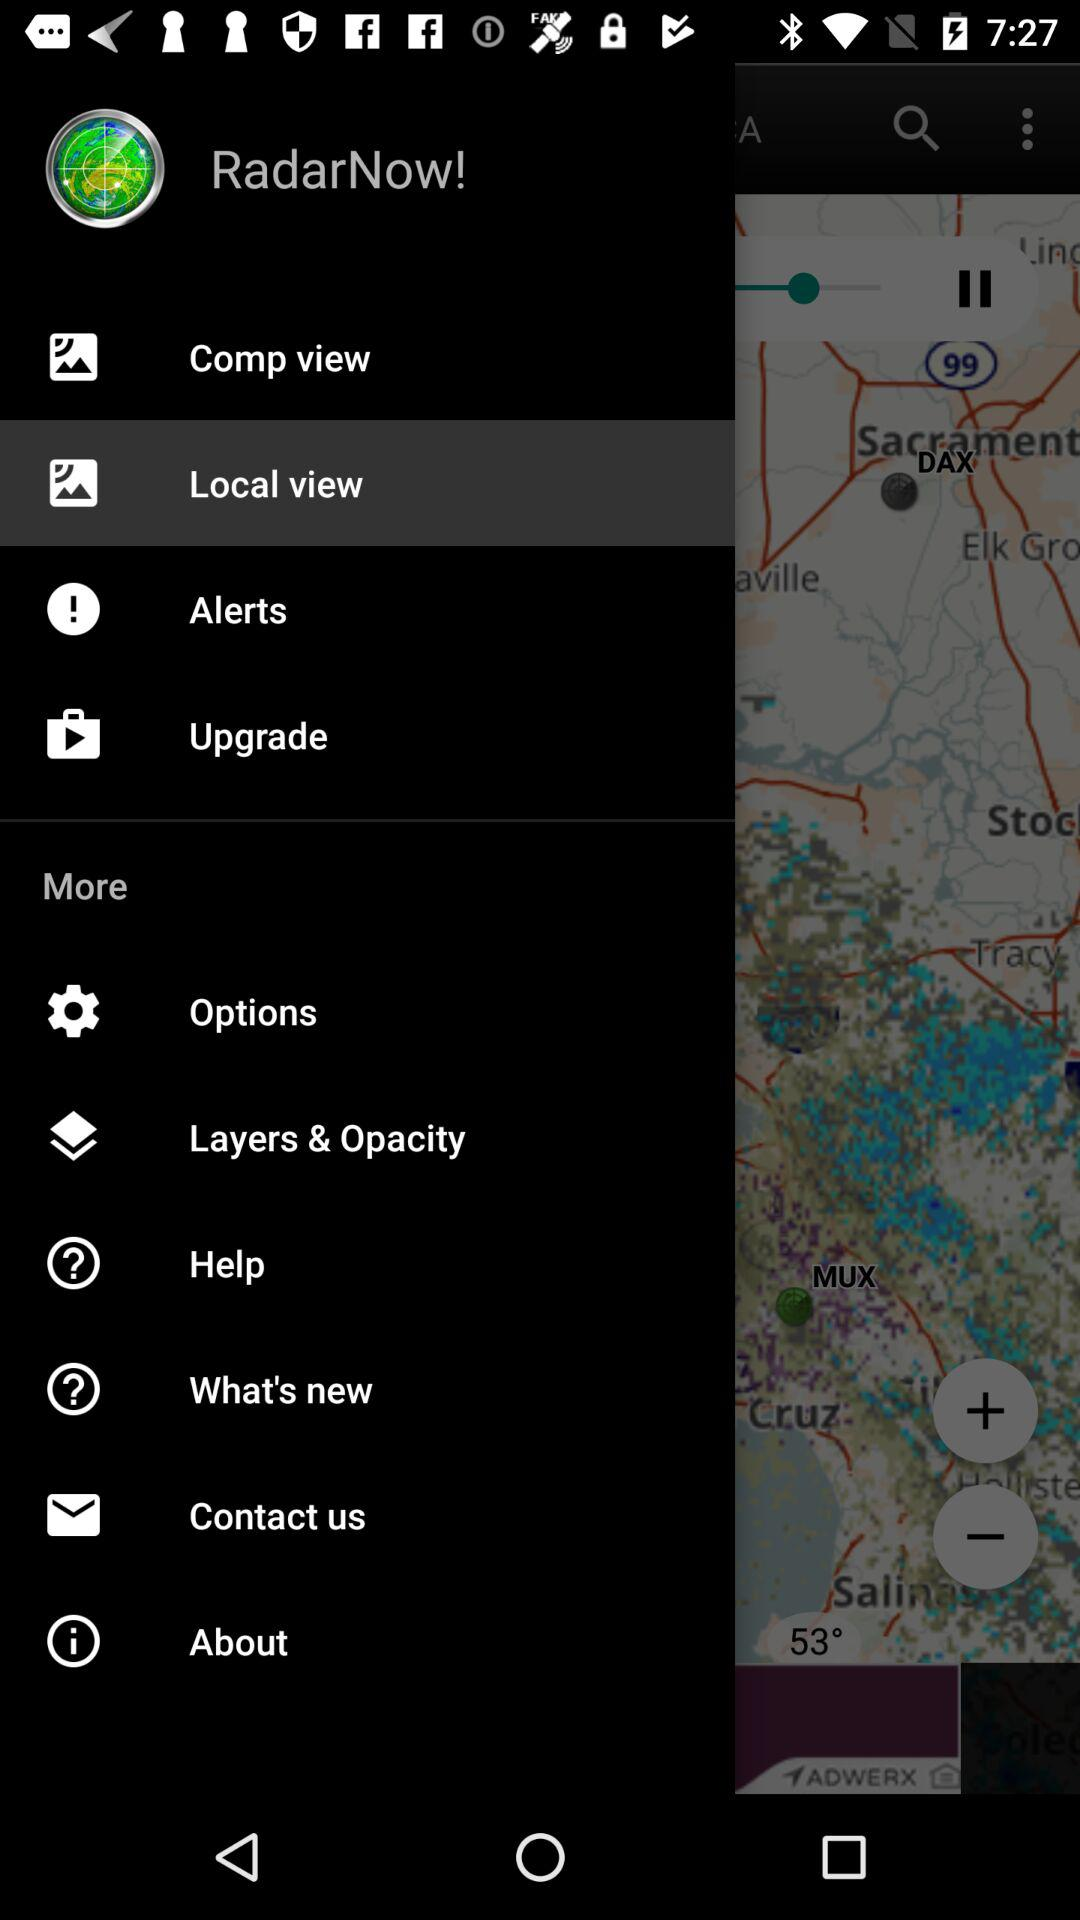Which item is highlighted? The item that is highlighted is "Local view". 